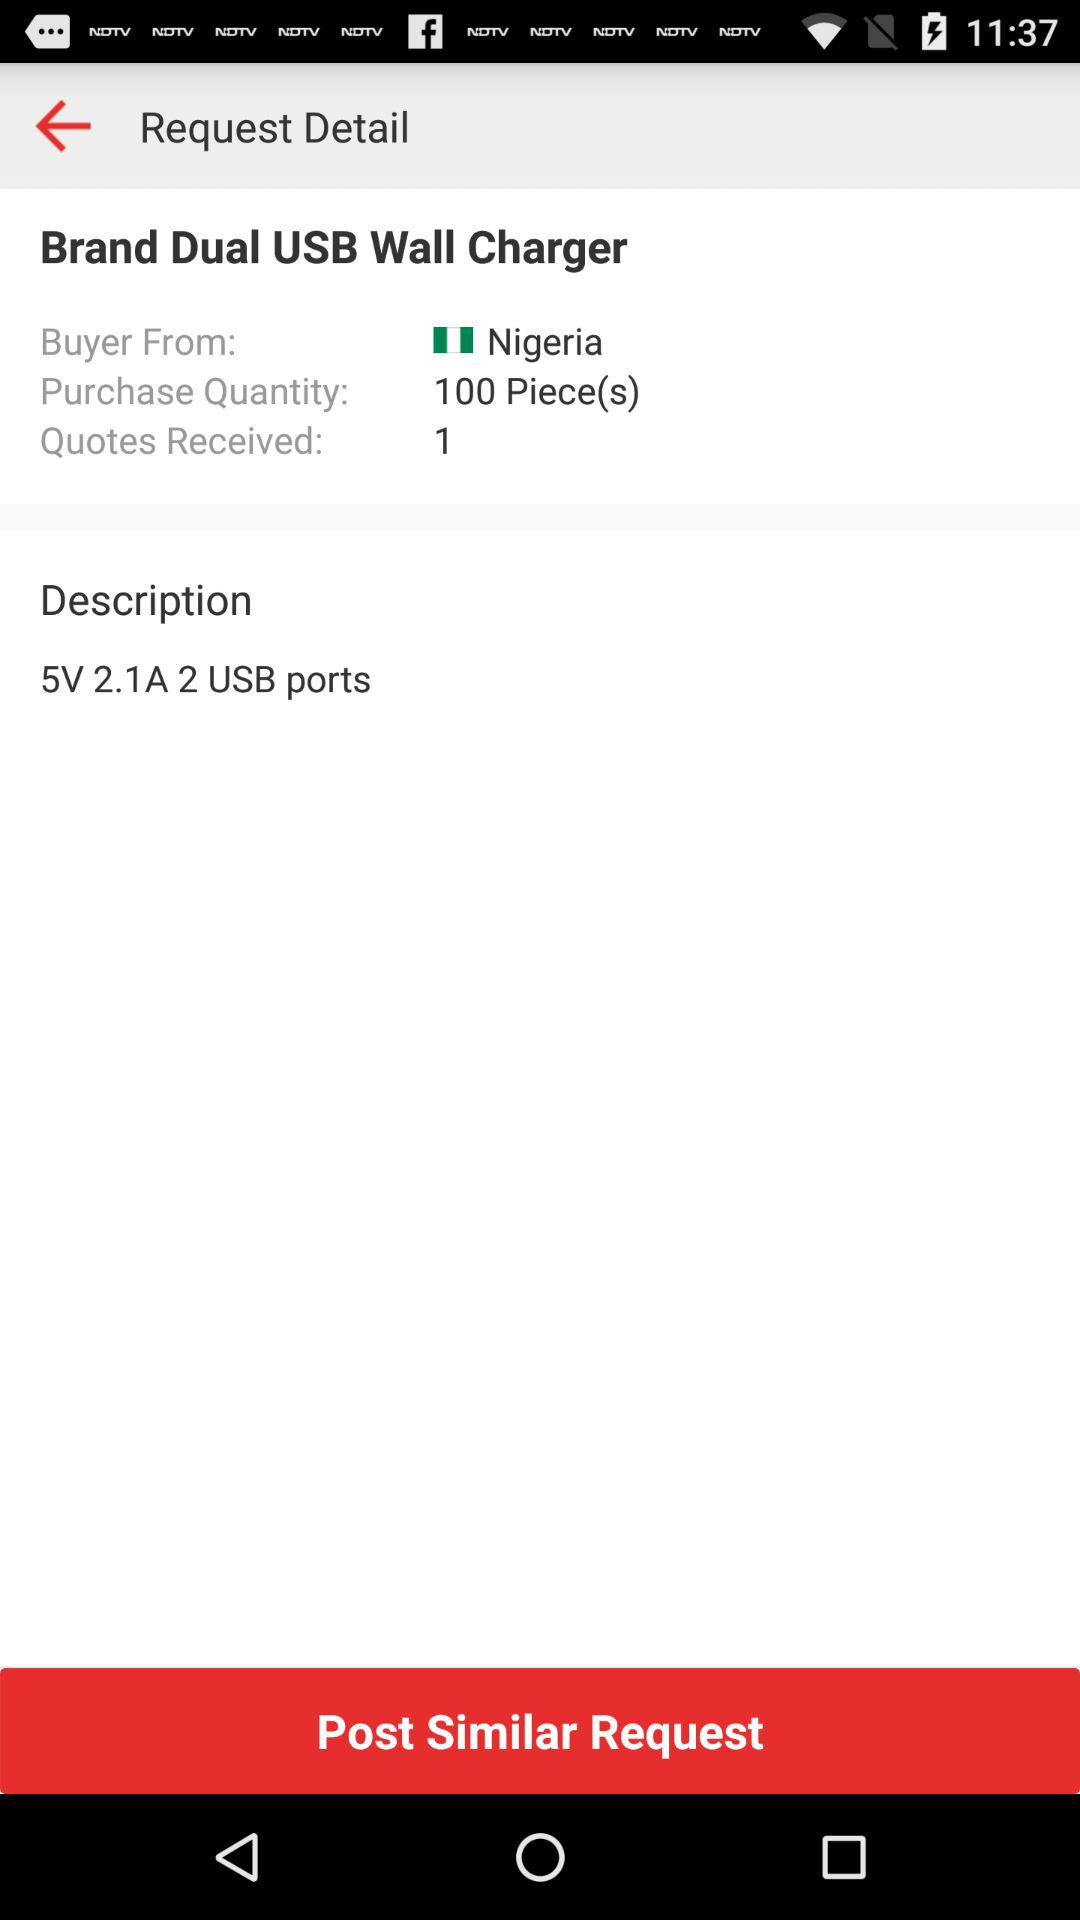Where is the buyer from? The buyer is from Nigeria. 